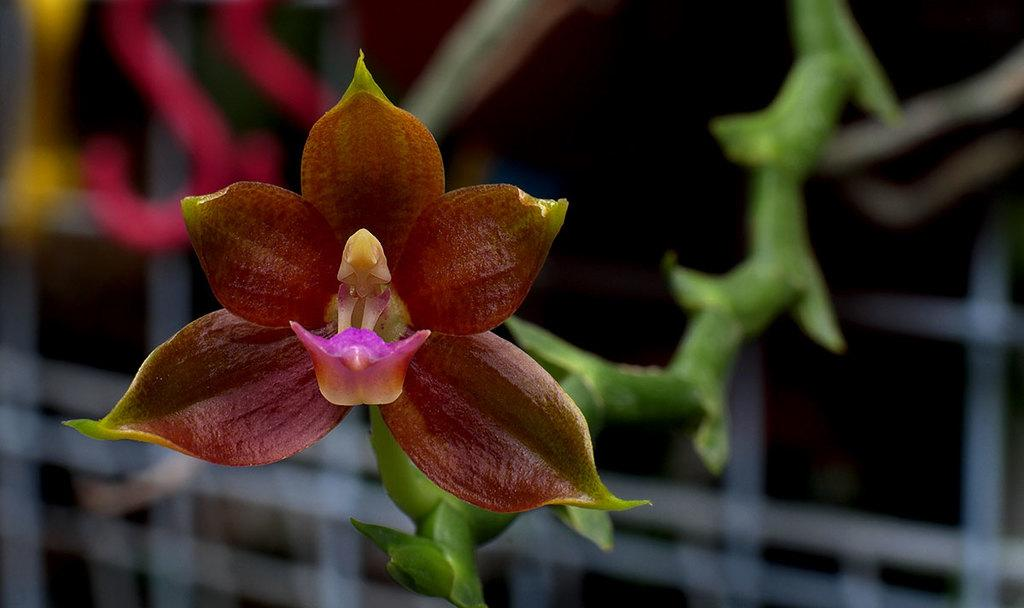What is the main subject of the image? There is a flower in the image. Can you describe the flower's position in relation to the plant? The flower is on the stem of a plant. Where is the flower located within the image? The flower is located in the middle of the image. How many babies are crawling around the flower in the image? There are no babies present in the image; it features a flower on a plant's stem. What type of meal is being prepared near the flower in the image? There is no meal preparation or any indication of food in the image; it only shows a flower on a plant's stem. 